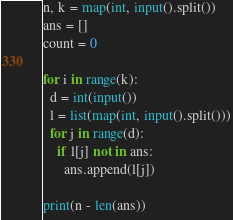<code> <loc_0><loc_0><loc_500><loc_500><_Python_>n, k = map(int, input().split())
ans = []
count = 0

for i in range(k):
  d = int(input())
  l = list(map(int, input().split()))
  for j in range(d):
    if l[j] not in ans:
      ans.append(l[j])
  
print(n - len(ans))</code> 